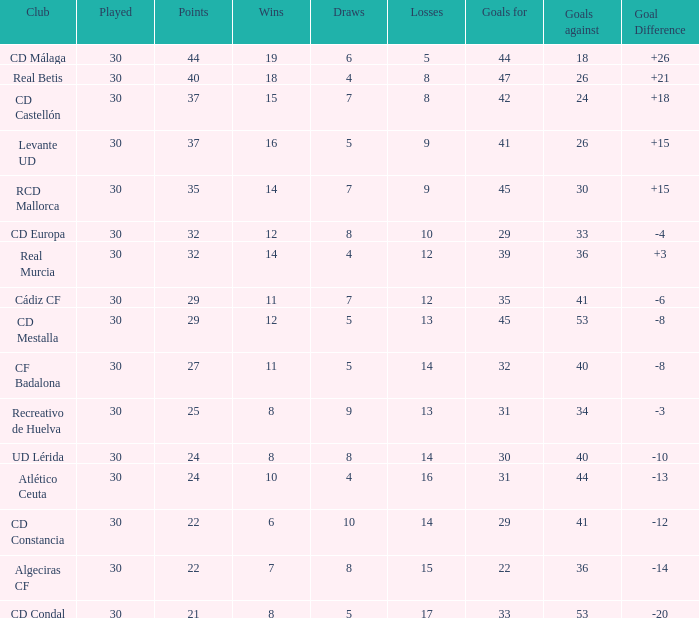What is the number of draws when played is smaller than 30? 0.0. 